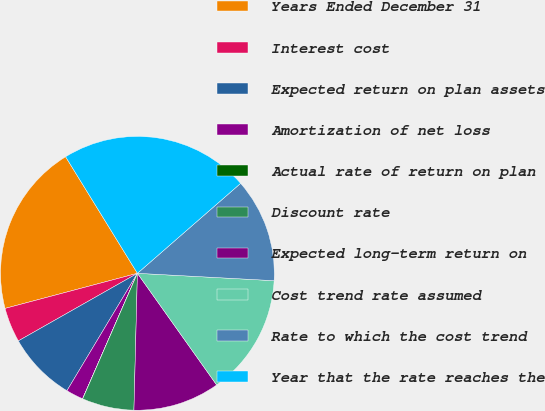<chart> <loc_0><loc_0><loc_500><loc_500><pie_chart><fcel>Years Ended December 31<fcel>Interest cost<fcel>Expected return on plan assets<fcel>Amortization of net loss<fcel>Actual rate of return on plan<fcel>Discount rate<fcel>Expected long-term return on<fcel>Cost trend rate assumed<fcel>Rate to which the cost trend<fcel>Year that the rate reaches the<nl><fcel>20.34%<fcel>4.09%<fcel>8.18%<fcel>2.05%<fcel>0.01%<fcel>6.14%<fcel>10.23%<fcel>14.32%<fcel>12.27%<fcel>22.38%<nl></chart> 